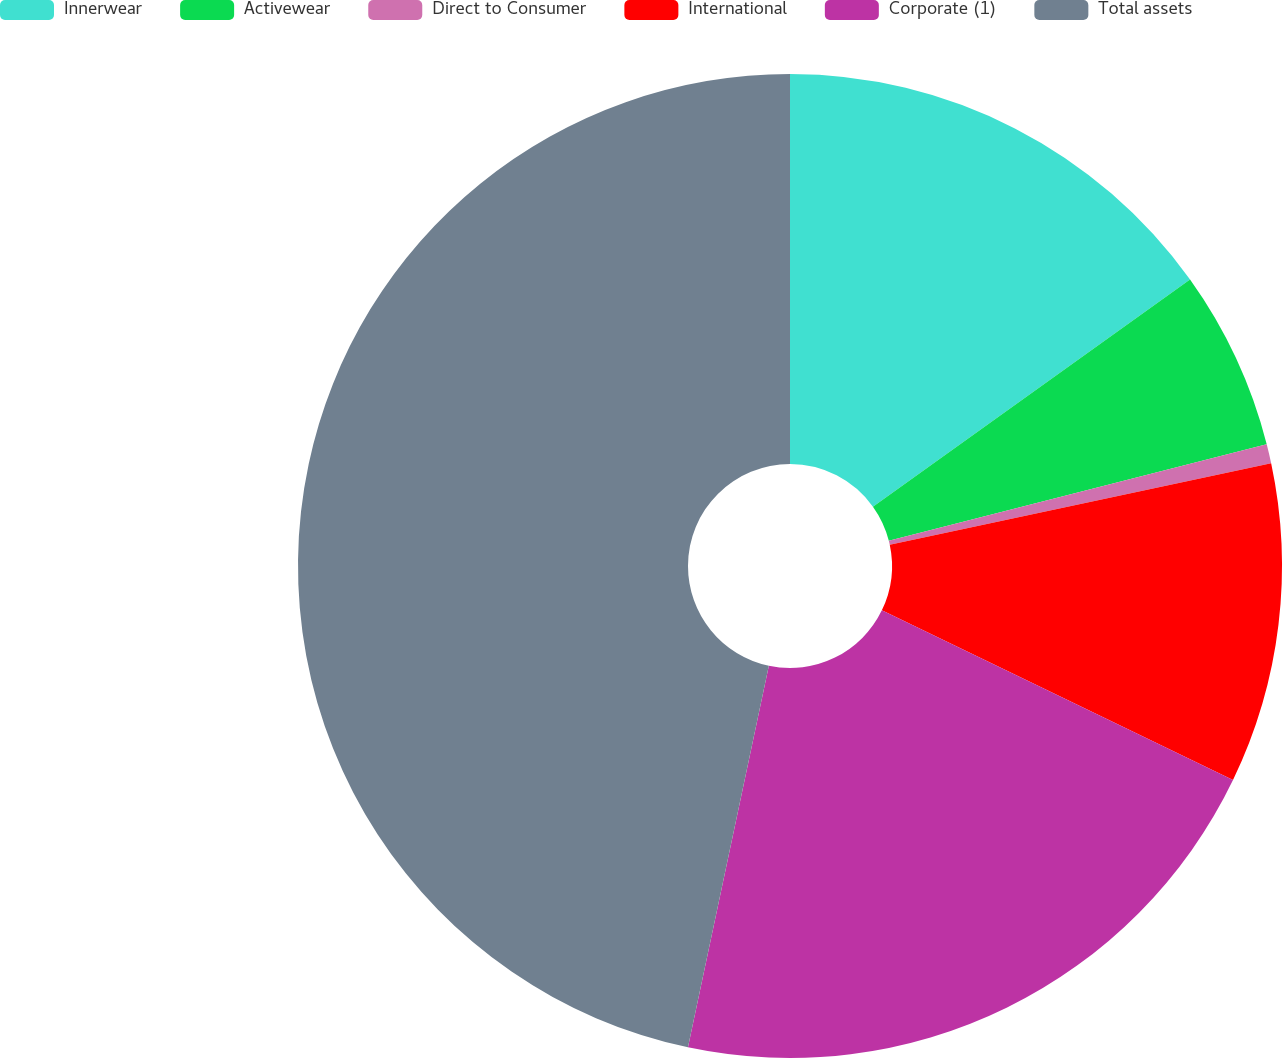Convert chart. <chart><loc_0><loc_0><loc_500><loc_500><pie_chart><fcel>Innerwear<fcel>Activewear<fcel>Direct to Consumer<fcel>International<fcel>Corporate (1)<fcel>Total assets<nl><fcel>15.11%<fcel>5.91%<fcel>0.63%<fcel>10.51%<fcel>21.16%<fcel>46.67%<nl></chart> 